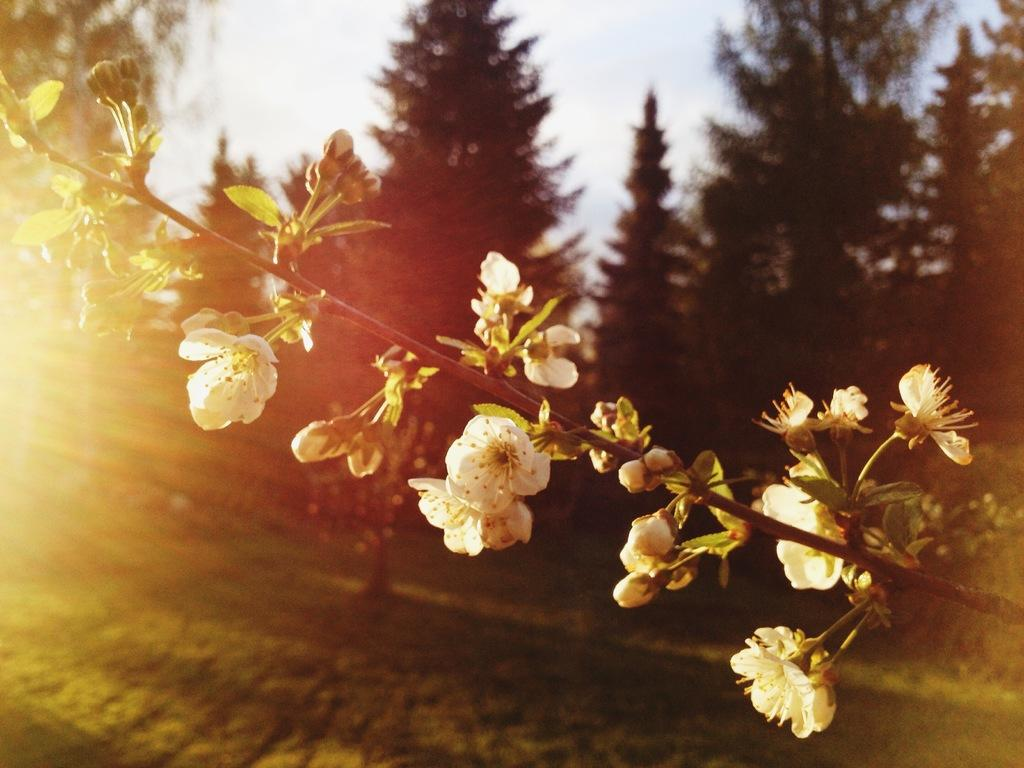What color are the flowers in the image? The flowers in the image are white. What type of vegetation is at the bottom of the image? There is green grass at the bottom of the image. What can be seen in the background of the image? There are many trees in the background of the image. What is visible at the top of the image? The sky is visible at the top of the image. How many planes are flying in the image? There are no planes visible in the image. Is there any driving activity taking place in the image? There is no driving activity present in the image. 